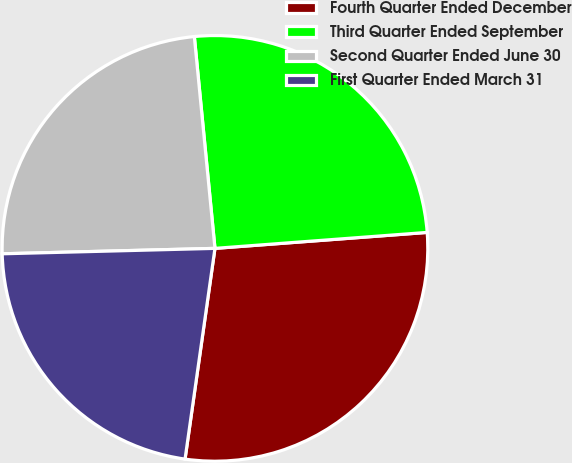Convert chart. <chart><loc_0><loc_0><loc_500><loc_500><pie_chart><fcel>Fourth Quarter Ended December<fcel>Third Quarter Ended September<fcel>Second Quarter Ended June 30<fcel>First Quarter Ended March 31<nl><fcel>28.44%<fcel>25.35%<fcel>23.86%<fcel>22.35%<nl></chart> 